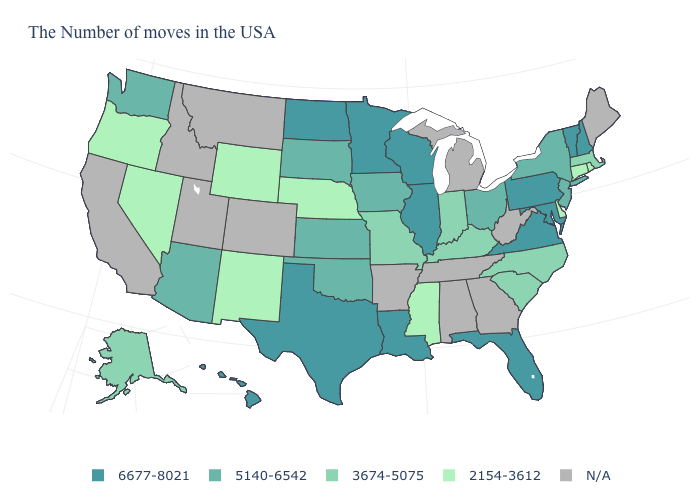What is the value of Nebraska?
Answer briefly. 2154-3612. What is the value of North Dakota?
Write a very short answer. 6677-8021. Which states hav the highest value in the Northeast?
Be succinct. New Hampshire, Vermont, Pennsylvania. Which states have the lowest value in the Northeast?
Give a very brief answer. Rhode Island, Connecticut. Does North Carolina have the highest value in the USA?
Give a very brief answer. No. Name the states that have a value in the range 3674-5075?
Keep it brief. Massachusetts, North Carolina, South Carolina, Kentucky, Indiana, Missouri, Alaska. Which states hav the highest value in the MidWest?
Give a very brief answer. Wisconsin, Illinois, Minnesota, North Dakota. Which states have the lowest value in the MidWest?
Keep it brief. Nebraska. Among the states that border Idaho , does Nevada have the highest value?
Short answer required. No. Does the first symbol in the legend represent the smallest category?
Give a very brief answer. No. Name the states that have a value in the range 5140-6542?
Give a very brief answer. New York, New Jersey, Ohio, Iowa, Kansas, Oklahoma, South Dakota, Arizona, Washington. How many symbols are there in the legend?
Concise answer only. 5. Name the states that have a value in the range 2154-3612?
Write a very short answer. Rhode Island, Connecticut, Delaware, Mississippi, Nebraska, Wyoming, New Mexico, Nevada, Oregon. 